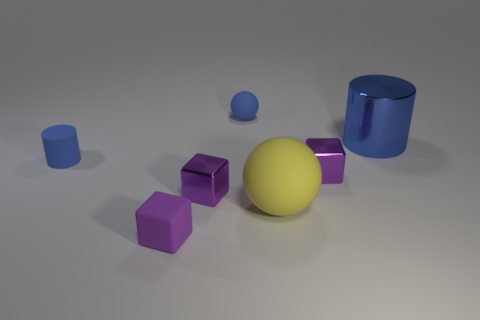Do the blue shiny cylinder and the blue matte cylinder have the same size?
Keep it short and to the point. No. Does the large metal cylinder have the same color as the tiny ball behind the large yellow object?
Make the answer very short. Yes. What shape is the small purple thing that is made of the same material as the yellow ball?
Your response must be concise. Cube. Is the shape of the small purple metallic object that is left of the tiny blue sphere the same as  the yellow thing?
Make the answer very short. No. What is the size of the blue object that is in front of the big object that is behind the yellow ball?
Offer a terse response. Small. There is a cylinder that is the same material as the big yellow ball; what color is it?
Make the answer very short. Blue. What number of purple objects are the same size as the purple matte cube?
Provide a short and direct response. 2. How many yellow objects are either big rubber things or small objects?
Offer a terse response. 1. What number of objects are either big things or blue objects that are behind the blue matte cylinder?
Give a very brief answer. 3. There is a blue cylinder that is right of the tiny rubber sphere; what material is it?
Your answer should be compact. Metal. 